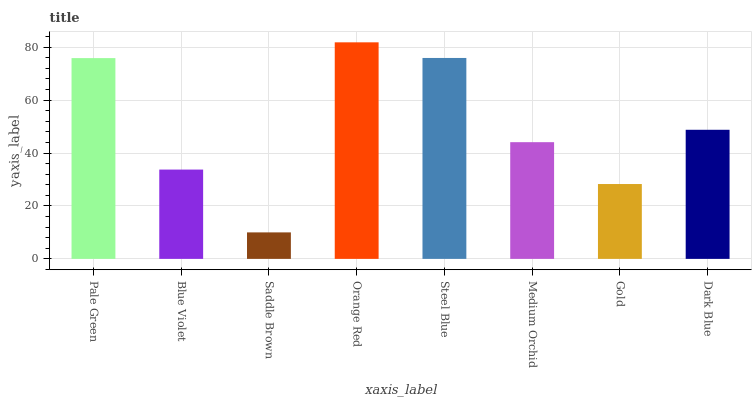Is Saddle Brown the minimum?
Answer yes or no. Yes. Is Orange Red the maximum?
Answer yes or no. Yes. Is Blue Violet the minimum?
Answer yes or no. No. Is Blue Violet the maximum?
Answer yes or no. No. Is Pale Green greater than Blue Violet?
Answer yes or no. Yes. Is Blue Violet less than Pale Green?
Answer yes or no. Yes. Is Blue Violet greater than Pale Green?
Answer yes or no. No. Is Pale Green less than Blue Violet?
Answer yes or no. No. Is Dark Blue the high median?
Answer yes or no. Yes. Is Medium Orchid the low median?
Answer yes or no. Yes. Is Steel Blue the high median?
Answer yes or no. No. Is Blue Violet the low median?
Answer yes or no. No. 